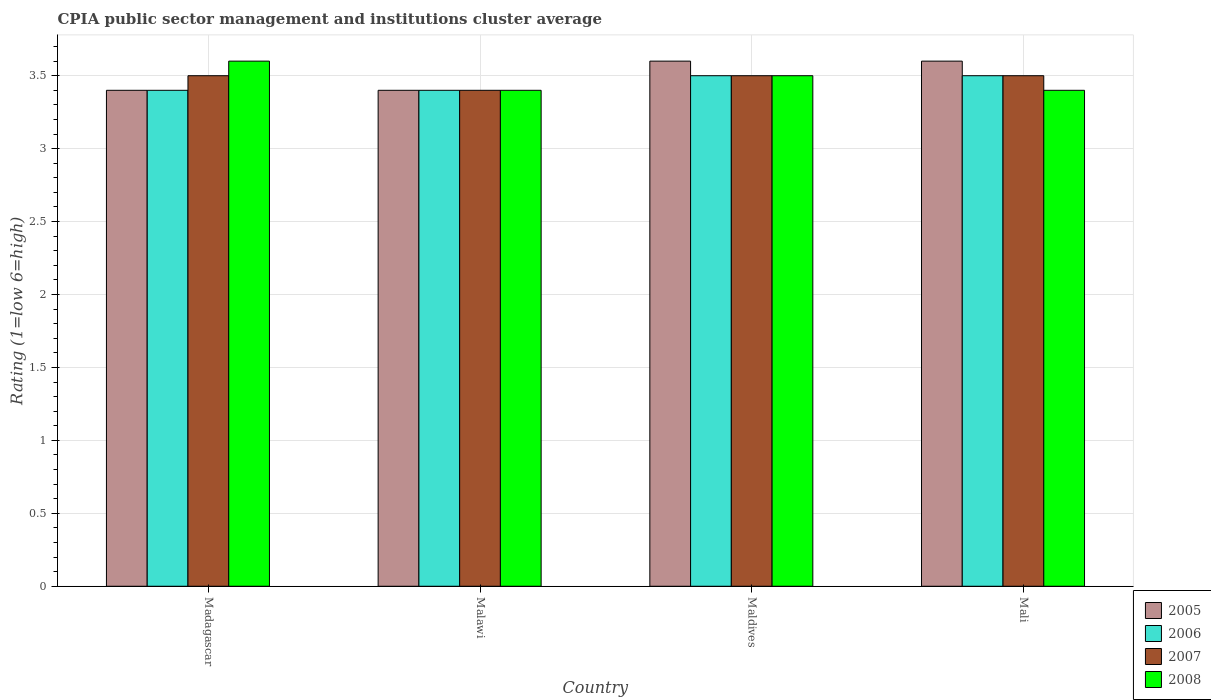How many different coloured bars are there?
Offer a terse response. 4. How many groups of bars are there?
Offer a very short reply. 4. Are the number of bars on each tick of the X-axis equal?
Your response must be concise. Yes. What is the label of the 3rd group of bars from the left?
Ensure brevity in your answer.  Maldives. In how many cases, is the number of bars for a given country not equal to the number of legend labels?
Provide a succinct answer. 0. What is the CPIA rating in 2007 in Malawi?
Provide a succinct answer. 3.4. Across all countries, what is the minimum CPIA rating in 2006?
Your response must be concise. 3.4. In which country was the CPIA rating in 2006 maximum?
Your answer should be compact. Maldives. In which country was the CPIA rating in 2006 minimum?
Give a very brief answer. Madagascar. What is the total CPIA rating in 2005 in the graph?
Ensure brevity in your answer.  14. What is the difference between the CPIA rating in 2006 in Madagascar and that in Malawi?
Give a very brief answer. 0. What is the difference between the CPIA rating in 2007 in Mali and the CPIA rating in 2005 in Maldives?
Provide a succinct answer. -0.1. What is the average CPIA rating in 2007 per country?
Ensure brevity in your answer.  3.48. What is the difference between the CPIA rating of/in 2006 and CPIA rating of/in 2008 in Madagascar?
Give a very brief answer. -0.2. What is the ratio of the CPIA rating in 2005 in Madagascar to that in Maldives?
Ensure brevity in your answer.  0.94. Is the CPIA rating in 2007 in Malawi less than that in Mali?
Offer a terse response. Yes. Is the difference between the CPIA rating in 2006 in Madagascar and Malawi greater than the difference between the CPIA rating in 2008 in Madagascar and Malawi?
Give a very brief answer. No. What is the difference between the highest and the second highest CPIA rating in 2008?
Offer a terse response. -0.1. What is the difference between the highest and the lowest CPIA rating in 2005?
Provide a short and direct response. 0.2. Is the sum of the CPIA rating in 2005 in Malawi and Maldives greater than the maximum CPIA rating in 2006 across all countries?
Your answer should be very brief. Yes. Is it the case that in every country, the sum of the CPIA rating in 2008 and CPIA rating in 2007 is greater than the sum of CPIA rating in 2006 and CPIA rating in 2005?
Ensure brevity in your answer.  No. What does the 1st bar from the left in Maldives represents?
Provide a succinct answer. 2005. What does the 2nd bar from the right in Malawi represents?
Your answer should be compact. 2007. Are all the bars in the graph horizontal?
Make the answer very short. No. How many countries are there in the graph?
Your answer should be compact. 4. What is the difference between two consecutive major ticks on the Y-axis?
Offer a very short reply. 0.5. Does the graph contain any zero values?
Offer a terse response. No. Where does the legend appear in the graph?
Offer a very short reply. Bottom right. How many legend labels are there?
Your answer should be very brief. 4. How are the legend labels stacked?
Offer a very short reply. Vertical. What is the title of the graph?
Ensure brevity in your answer.  CPIA public sector management and institutions cluster average. What is the Rating (1=low 6=high) of 2008 in Madagascar?
Provide a short and direct response. 3.6. What is the Rating (1=low 6=high) of 2005 in Malawi?
Give a very brief answer. 3.4. What is the Rating (1=low 6=high) in 2006 in Malawi?
Keep it short and to the point. 3.4. What is the Rating (1=low 6=high) in 2007 in Malawi?
Give a very brief answer. 3.4. What is the Rating (1=low 6=high) of 2005 in Maldives?
Ensure brevity in your answer.  3.6. What is the Rating (1=low 6=high) in 2006 in Maldives?
Provide a succinct answer. 3.5. What is the Rating (1=low 6=high) in 2005 in Mali?
Provide a short and direct response. 3.6. What is the Rating (1=low 6=high) in 2008 in Mali?
Ensure brevity in your answer.  3.4. Across all countries, what is the maximum Rating (1=low 6=high) of 2005?
Provide a succinct answer. 3.6. Across all countries, what is the maximum Rating (1=low 6=high) in 2006?
Provide a short and direct response. 3.5. Across all countries, what is the minimum Rating (1=low 6=high) of 2005?
Provide a short and direct response. 3.4. Across all countries, what is the minimum Rating (1=low 6=high) in 2006?
Provide a succinct answer. 3.4. Across all countries, what is the minimum Rating (1=low 6=high) of 2007?
Your answer should be very brief. 3.4. What is the difference between the Rating (1=low 6=high) in 2005 in Madagascar and that in Malawi?
Your response must be concise. 0. What is the difference between the Rating (1=low 6=high) in 2006 in Madagascar and that in Malawi?
Your answer should be compact. 0. What is the difference between the Rating (1=low 6=high) in 2008 in Madagascar and that in Malawi?
Offer a terse response. 0.2. What is the difference between the Rating (1=low 6=high) in 2008 in Madagascar and that in Maldives?
Give a very brief answer. 0.1. What is the difference between the Rating (1=low 6=high) in 2006 in Madagascar and that in Mali?
Your answer should be compact. -0.1. What is the difference between the Rating (1=low 6=high) in 2007 in Madagascar and that in Mali?
Give a very brief answer. 0. What is the difference between the Rating (1=low 6=high) of 2006 in Malawi and that in Maldives?
Offer a terse response. -0.1. What is the difference between the Rating (1=low 6=high) in 2007 in Malawi and that in Maldives?
Offer a terse response. -0.1. What is the difference between the Rating (1=low 6=high) in 2005 in Malawi and that in Mali?
Ensure brevity in your answer.  -0.2. What is the difference between the Rating (1=low 6=high) in 2007 in Malawi and that in Mali?
Offer a terse response. -0.1. What is the difference between the Rating (1=low 6=high) in 2008 in Malawi and that in Mali?
Your response must be concise. 0. What is the difference between the Rating (1=low 6=high) in 2005 in Maldives and that in Mali?
Offer a terse response. 0. What is the difference between the Rating (1=low 6=high) of 2008 in Maldives and that in Mali?
Keep it short and to the point. 0.1. What is the difference between the Rating (1=low 6=high) of 2005 in Madagascar and the Rating (1=low 6=high) of 2007 in Malawi?
Your answer should be compact. 0. What is the difference between the Rating (1=low 6=high) in 2006 in Madagascar and the Rating (1=low 6=high) in 2007 in Malawi?
Your answer should be compact. 0. What is the difference between the Rating (1=low 6=high) in 2006 in Madagascar and the Rating (1=low 6=high) in 2008 in Malawi?
Ensure brevity in your answer.  0. What is the difference between the Rating (1=low 6=high) in 2005 in Madagascar and the Rating (1=low 6=high) in 2007 in Maldives?
Provide a succinct answer. -0.1. What is the difference between the Rating (1=low 6=high) of 2005 in Madagascar and the Rating (1=low 6=high) of 2008 in Maldives?
Offer a very short reply. -0.1. What is the difference between the Rating (1=low 6=high) in 2006 in Madagascar and the Rating (1=low 6=high) in 2007 in Maldives?
Keep it short and to the point. -0.1. What is the difference between the Rating (1=low 6=high) of 2007 in Madagascar and the Rating (1=low 6=high) of 2008 in Maldives?
Offer a very short reply. 0. What is the difference between the Rating (1=low 6=high) in 2005 in Madagascar and the Rating (1=low 6=high) in 2008 in Mali?
Provide a succinct answer. 0. What is the difference between the Rating (1=low 6=high) in 2005 in Malawi and the Rating (1=low 6=high) in 2006 in Maldives?
Provide a succinct answer. -0.1. What is the difference between the Rating (1=low 6=high) of 2005 in Malawi and the Rating (1=low 6=high) of 2008 in Maldives?
Your answer should be very brief. -0.1. What is the difference between the Rating (1=low 6=high) in 2007 in Malawi and the Rating (1=low 6=high) in 2008 in Maldives?
Your answer should be compact. -0.1. What is the difference between the Rating (1=low 6=high) in 2006 in Malawi and the Rating (1=low 6=high) in 2007 in Mali?
Offer a very short reply. -0.1. What is the difference between the Rating (1=low 6=high) in 2006 in Malawi and the Rating (1=low 6=high) in 2008 in Mali?
Offer a terse response. 0. What is the difference between the Rating (1=low 6=high) of 2007 in Malawi and the Rating (1=low 6=high) of 2008 in Mali?
Offer a very short reply. 0. What is the difference between the Rating (1=low 6=high) in 2005 in Maldives and the Rating (1=low 6=high) in 2007 in Mali?
Offer a very short reply. 0.1. What is the difference between the Rating (1=low 6=high) of 2005 in Maldives and the Rating (1=low 6=high) of 2008 in Mali?
Your answer should be compact. 0.2. What is the difference between the Rating (1=low 6=high) of 2006 in Maldives and the Rating (1=low 6=high) of 2008 in Mali?
Your response must be concise. 0.1. What is the average Rating (1=low 6=high) in 2006 per country?
Keep it short and to the point. 3.45. What is the average Rating (1=low 6=high) of 2007 per country?
Make the answer very short. 3.48. What is the average Rating (1=low 6=high) in 2008 per country?
Give a very brief answer. 3.48. What is the difference between the Rating (1=low 6=high) of 2006 and Rating (1=low 6=high) of 2007 in Madagascar?
Keep it short and to the point. -0.1. What is the difference between the Rating (1=low 6=high) of 2006 and Rating (1=low 6=high) of 2008 in Madagascar?
Make the answer very short. -0.2. What is the difference between the Rating (1=low 6=high) in 2005 and Rating (1=low 6=high) in 2007 in Malawi?
Provide a succinct answer. 0. What is the difference between the Rating (1=low 6=high) in 2006 and Rating (1=low 6=high) in 2007 in Malawi?
Ensure brevity in your answer.  0. What is the difference between the Rating (1=low 6=high) in 2005 and Rating (1=low 6=high) in 2007 in Maldives?
Your answer should be compact. 0.1. What is the difference between the Rating (1=low 6=high) of 2005 and Rating (1=low 6=high) of 2008 in Maldives?
Keep it short and to the point. 0.1. What is the difference between the Rating (1=low 6=high) in 2006 and Rating (1=low 6=high) in 2008 in Maldives?
Your answer should be compact. 0. What is the difference between the Rating (1=low 6=high) in 2005 and Rating (1=low 6=high) in 2006 in Mali?
Your answer should be compact. 0.1. What is the difference between the Rating (1=low 6=high) in 2005 and Rating (1=low 6=high) in 2007 in Mali?
Keep it short and to the point. 0.1. What is the difference between the Rating (1=low 6=high) of 2005 and Rating (1=low 6=high) of 2008 in Mali?
Offer a very short reply. 0.2. What is the difference between the Rating (1=low 6=high) in 2006 and Rating (1=low 6=high) in 2007 in Mali?
Make the answer very short. 0. What is the ratio of the Rating (1=low 6=high) of 2007 in Madagascar to that in Malawi?
Offer a terse response. 1.03. What is the ratio of the Rating (1=low 6=high) of 2008 in Madagascar to that in Malawi?
Give a very brief answer. 1.06. What is the ratio of the Rating (1=low 6=high) in 2006 in Madagascar to that in Maldives?
Ensure brevity in your answer.  0.97. What is the ratio of the Rating (1=low 6=high) of 2007 in Madagascar to that in Maldives?
Provide a short and direct response. 1. What is the ratio of the Rating (1=low 6=high) of 2008 in Madagascar to that in Maldives?
Offer a terse response. 1.03. What is the ratio of the Rating (1=low 6=high) in 2005 in Madagascar to that in Mali?
Provide a succinct answer. 0.94. What is the ratio of the Rating (1=low 6=high) of 2006 in Madagascar to that in Mali?
Offer a terse response. 0.97. What is the ratio of the Rating (1=low 6=high) of 2007 in Madagascar to that in Mali?
Offer a terse response. 1. What is the ratio of the Rating (1=low 6=high) in 2008 in Madagascar to that in Mali?
Ensure brevity in your answer.  1.06. What is the ratio of the Rating (1=low 6=high) of 2005 in Malawi to that in Maldives?
Your answer should be very brief. 0.94. What is the ratio of the Rating (1=low 6=high) in 2006 in Malawi to that in Maldives?
Your answer should be very brief. 0.97. What is the ratio of the Rating (1=low 6=high) of 2007 in Malawi to that in Maldives?
Ensure brevity in your answer.  0.97. What is the ratio of the Rating (1=low 6=high) in 2008 in Malawi to that in Maldives?
Provide a succinct answer. 0.97. What is the ratio of the Rating (1=low 6=high) in 2005 in Malawi to that in Mali?
Give a very brief answer. 0.94. What is the ratio of the Rating (1=low 6=high) of 2006 in Malawi to that in Mali?
Offer a terse response. 0.97. What is the ratio of the Rating (1=low 6=high) in 2007 in Malawi to that in Mali?
Your answer should be compact. 0.97. What is the ratio of the Rating (1=low 6=high) in 2008 in Malawi to that in Mali?
Offer a very short reply. 1. What is the ratio of the Rating (1=low 6=high) of 2006 in Maldives to that in Mali?
Give a very brief answer. 1. What is the ratio of the Rating (1=low 6=high) in 2008 in Maldives to that in Mali?
Ensure brevity in your answer.  1.03. What is the difference between the highest and the second highest Rating (1=low 6=high) of 2005?
Make the answer very short. 0. What is the difference between the highest and the second highest Rating (1=low 6=high) in 2006?
Provide a succinct answer. 0. What is the difference between the highest and the lowest Rating (1=low 6=high) of 2006?
Your response must be concise. 0.1. What is the difference between the highest and the lowest Rating (1=low 6=high) of 2007?
Ensure brevity in your answer.  0.1. What is the difference between the highest and the lowest Rating (1=low 6=high) in 2008?
Your response must be concise. 0.2. 